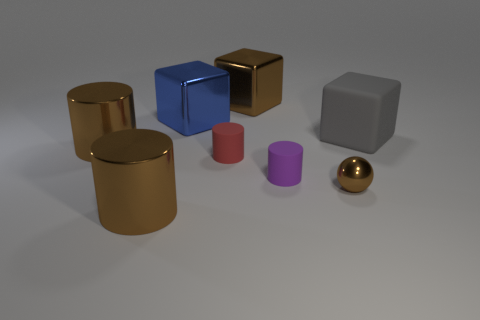What number of other things are there of the same shape as the red thing?
Give a very brief answer. 3. Do the matte block and the sphere have the same color?
Make the answer very short. No. How many things are either tiny brown metal balls or cubes to the left of the gray rubber block?
Offer a terse response. 3. Is there another brown cube that has the same size as the brown metallic cube?
Offer a terse response. No. Is the material of the sphere the same as the red thing?
Your answer should be very brief. No. How many objects are big brown shiny cylinders or tiny metal objects?
Offer a very short reply. 3. The brown block is what size?
Offer a very short reply. Large. Is the number of blue cylinders less than the number of blue objects?
Your response must be concise. Yes. What number of metallic cylinders have the same color as the big rubber object?
Your response must be concise. 0. There is a tiny object to the left of the tiny purple rubber object; is it the same color as the big matte object?
Provide a short and direct response. No. 